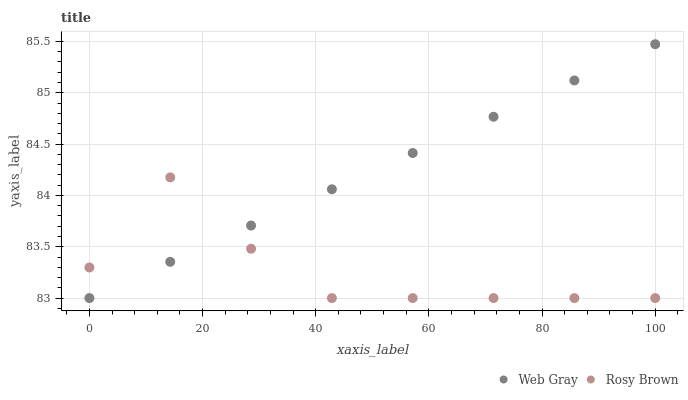Does Rosy Brown have the minimum area under the curve?
Answer yes or no. Yes. Does Web Gray have the maximum area under the curve?
Answer yes or no. Yes. Does Web Gray have the minimum area under the curve?
Answer yes or no. No. Is Web Gray the smoothest?
Answer yes or no. Yes. Is Rosy Brown the roughest?
Answer yes or no. Yes. Is Web Gray the roughest?
Answer yes or no. No. Does Rosy Brown have the lowest value?
Answer yes or no. Yes. Does Web Gray have the highest value?
Answer yes or no. Yes. Does Web Gray intersect Rosy Brown?
Answer yes or no. Yes. Is Web Gray less than Rosy Brown?
Answer yes or no. No. Is Web Gray greater than Rosy Brown?
Answer yes or no. No. 